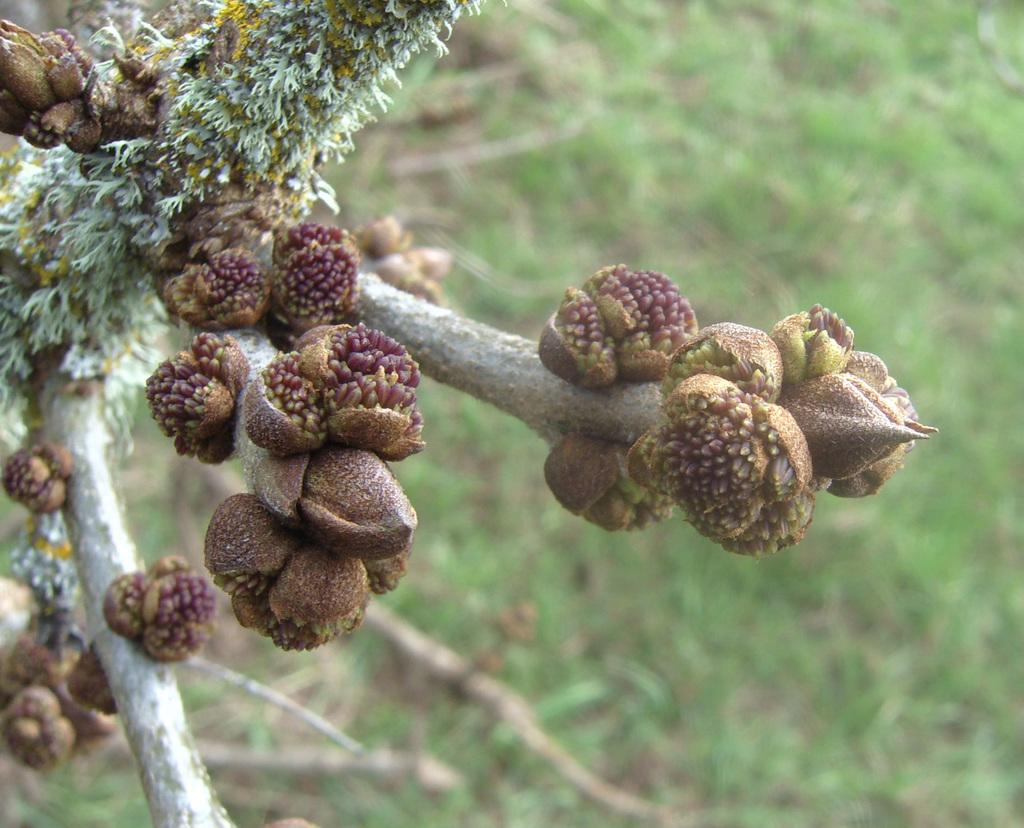What type of food can be seen in the image? There are fruits in the image. What colors are the fruits? The fruits have brown and purple colors. What can be seen in the background of the image? The background of the image is green. What is the limit of passengers allowed in the image? There is no reference to passengers or limits in the image, as it features fruits with brown and purple colors against a green background. 